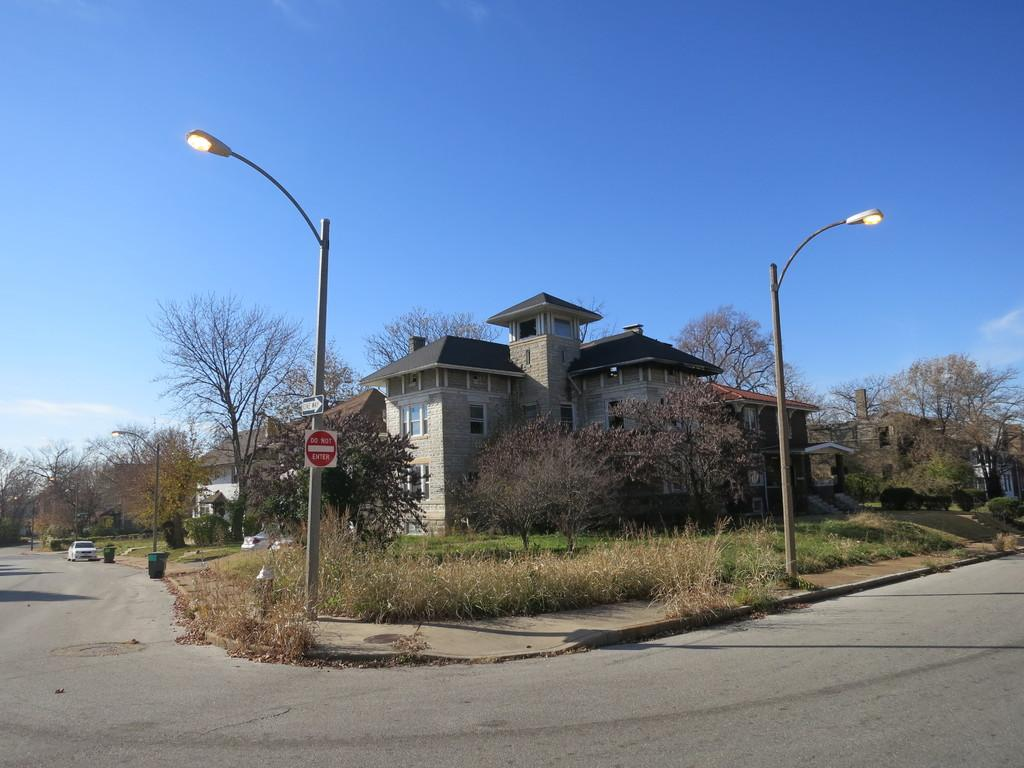<image>
Create a compact narrative representing the image presented. A sign on a light pole that says Do Not Enter 